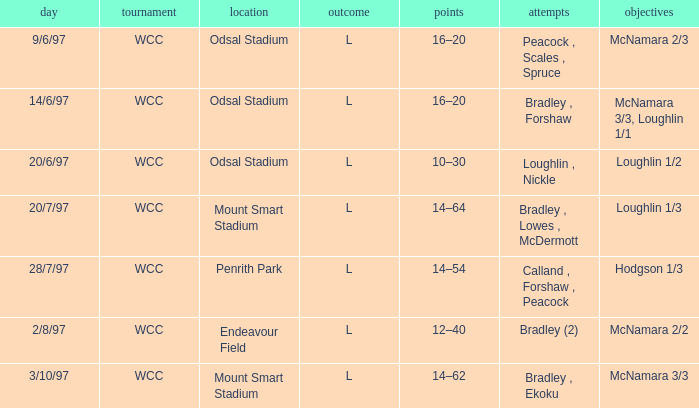What was the score on 20/6/97? 10–30. 